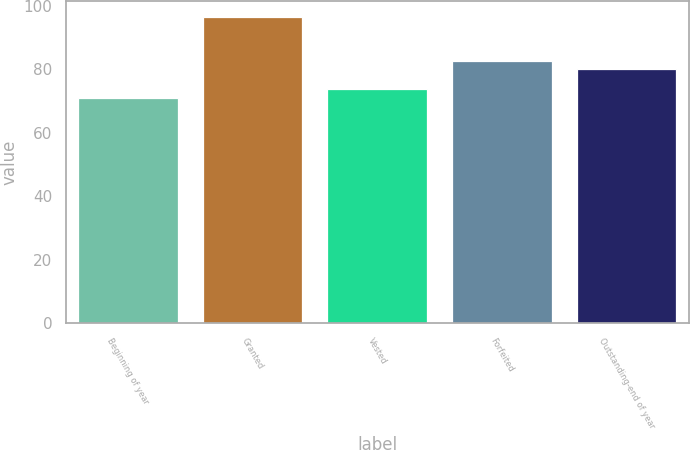Convert chart. <chart><loc_0><loc_0><loc_500><loc_500><bar_chart><fcel>Beginning of year<fcel>Granted<fcel>Vested<fcel>Forfeited<fcel>Outstanding-end of year<nl><fcel>71.03<fcel>96.59<fcel>73.59<fcel>82.64<fcel>80.08<nl></chart> 